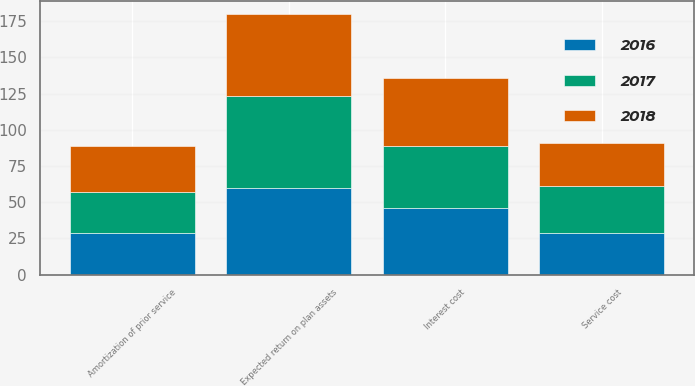<chart> <loc_0><loc_0><loc_500><loc_500><stacked_bar_chart><ecel><fcel>Service cost<fcel>Interest cost<fcel>Expected return on plan assets<fcel>Amortization of prior service<nl><fcel>2017<fcel>32<fcel>43<fcel>63<fcel>28<nl><fcel>2016<fcel>29<fcel>46<fcel>60<fcel>29<nl><fcel>2018<fcel>30<fcel>47<fcel>57<fcel>32<nl></chart> 